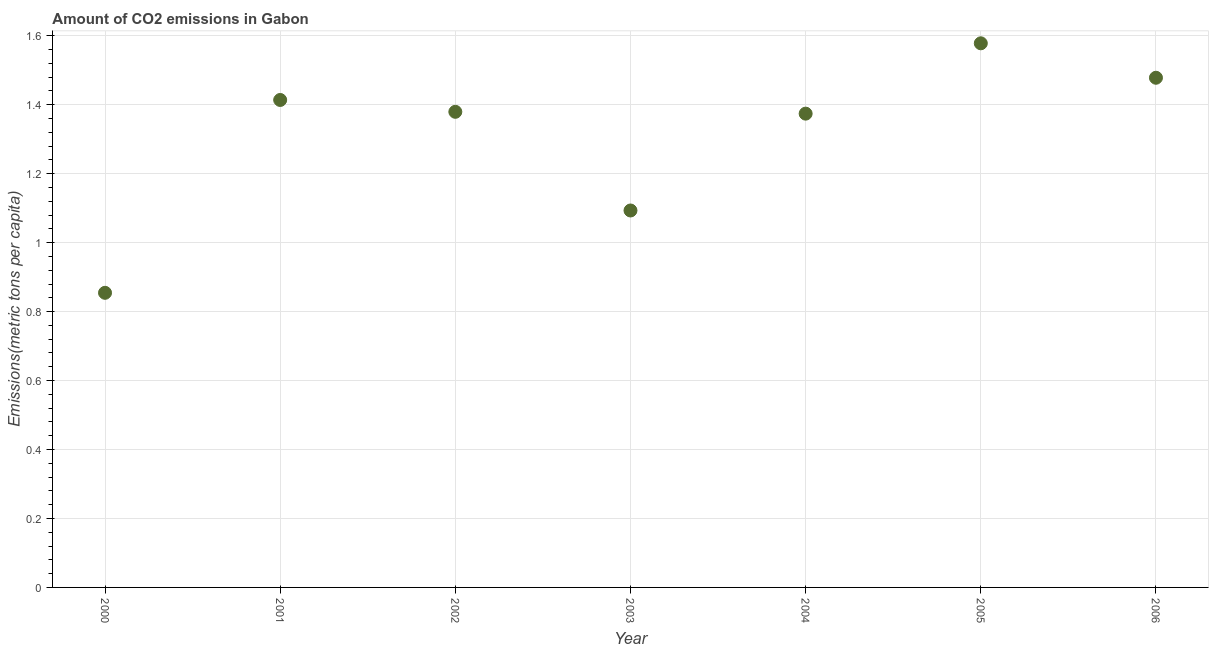What is the amount of co2 emissions in 2006?
Keep it short and to the point. 1.48. Across all years, what is the maximum amount of co2 emissions?
Provide a short and direct response. 1.58. Across all years, what is the minimum amount of co2 emissions?
Ensure brevity in your answer.  0.85. In which year was the amount of co2 emissions maximum?
Provide a short and direct response. 2005. What is the sum of the amount of co2 emissions?
Ensure brevity in your answer.  9.17. What is the difference between the amount of co2 emissions in 2004 and 2005?
Your answer should be very brief. -0.2. What is the average amount of co2 emissions per year?
Keep it short and to the point. 1.31. What is the median amount of co2 emissions?
Your answer should be compact. 1.38. In how many years, is the amount of co2 emissions greater than 0.68 metric tons per capita?
Offer a very short reply. 7. What is the ratio of the amount of co2 emissions in 2003 to that in 2006?
Your answer should be very brief. 0.74. Is the amount of co2 emissions in 2002 less than that in 2005?
Provide a short and direct response. Yes. What is the difference between the highest and the second highest amount of co2 emissions?
Your answer should be very brief. 0.1. What is the difference between the highest and the lowest amount of co2 emissions?
Your answer should be compact. 0.72. In how many years, is the amount of co2 emissions greater than the average amount of co2 emissions taken over all years?
Provide a short and direct response. 5. How many dotlines are there?
Ensure brevity in your answer.  1. Does the graph contain any zero values?
Keep it short and to the point. No. Does the graph contain grids?
Your answer should be very brief. Yes. What is the title of the graph?
Give a very brief answer. Amount of CO2 emissions in Gabon. What is the label or title of the Y-axis?
Make the answer very short. Emissions(metric tons per capita). What is the Emissions(metric tons per capita) in 2000?
Provide a short and direct response. 0.85. What is the Emissions(metric tons per capita) in 2001?
Provide a succinct answer. 1.41. What is the Emissions(metric tons per capita) in 2002?
Your answer should be very brief. 1.38. What is the Emissions(metric tons per capita) in 2003?
Your answer should be very brief. 1.09. What is the Emissions(metric tons per capita) in 2004?
Give a very brief answer. 1.37. What is the Emissions(metric tons per capita) in 2005?
Ensure brevity in your answer.  1.58. What is the Emissions(metric tons per capita) in 2006?
Ensure brevity in your answer.  1.48. What is the difference between the Emissions(metric tons per capita) in 2000 and 2001?
Keep it short and to the point. -0.56. What is the difference between the Emissions(metric tons per capita) in 2000 and 2002?
Your response must be concise. -0.52. What is the difference between the Emissions(metric tons per capita) in 2000 and 2003?
Ensure brevity in your answer.  -0.24. What is the difference between the Emissions(metric tons per capita) in 2000 and 2004?
Your answer should be very brief. -0.52. What is the difference between the Emissions(metric tons per capita) in 2000 and 2005?
Make the answer very short. -0.72. What is the difference between the Emissions(metric tons per capita) in 2000 and 2006?
Keep it short and to the point. -0.62. What is the difference between the Emissions(metric tons per capita) in 2001 and 2002?
Your answer should be very brief. 0.03. What is the difference between the Emissions(metric tons per capita) in 2001 and 2003?
Offer a terse response. 0.32. What is the difference between the Emissions(metric tons per capita) in 2001 and 2004?
Offer a very short reply. 0.04. What is the difference between the Emissions(metric tons per capita) in 2001 and 2005?
Keep it short and to the point. -0.16. What is the difference between the Emissions(metric tons per capita) in 2001 and 2006?
Your response must be concise. -0.06. What is the difference between the Emissions(metric tons per capita) in 2002 and 2003?
Your answer should be very brief. 0.29. What is the difference between the Emissions(metric tons per capita) in 2002 and 2004?
Your answer should be compact. 0.01. What is the difference between the Emissions(metric tons per capita) in 2002 and 2005?
Make the answer very short. -0.2. What is the difference between the Emissions(metric tons per capita) in 2002 and 2006?
Give a very brief answer. -0.1. What is the difference between the Emissions(metric tons per capita) in 2003 and 2004?
Ensure brevity in your answer.  -0.28. What is the difference between the Emissions(metric tons per capita) in 2003 and 2005?
Your response must be concise. -0.48. What is the difference between the Emissions(metric tons per capita) in 2003 and 2006?
Provide a short and direct response. -0.38. What is the difference between the Emissions(metric tons per capita) in 2004 and 2005?
Give a very brief answer. -0.2. What is the difference between the Emissions(metric tons per capita) in 2004 and 2006?
Offer a terse response. -0.1. What is the difference between the Emissions(metric tons per capita) in 2005 and 2006?
Offer a very short reply. 0.1. What is the ratio of the Emissions(metric tons per capita) in 2000 to that in 2001?
Make the answer very short. 0.6. What is the ratio of the Emissions(metric tons per capita) in 2000 to that in 2002?
Provide a succinct answer. 0.62. What is the ratio of the Emissions(metric tons per capita) in 2000 to that in 2003?
Make the answer very short. 0.78. What is the ratio of the Emissions(metric tons per capita) in 2000 to that in 2004?
Give a very brief answer. 0.62. What is the ratio of the Emissions(metric tons per capita) in 2000 to that in 2005?
Provide a short and direct response. 0.54. What is the ratio of the Emissions(metric tons per capita) in 2000 to that in 2006?
Your answer should be very brief. 0.58. What is the ratio of the Emissions(metric tons per capita) in 2001 to that in 2003?
Make the answer very short. 1.29. What is the ratio of the Emissions(metric tons per capita) in 2001 to that in 2004?
Offer a terse response. 1.03. What is the ratio of the Emissions(metric tons per capita) in 2001 to that in 2005?
Your response must be concise. 0.9. What is the ratio of the Emissions(metric tons per capita) in 2001 to that in 2006?
Give a very brief answer. 0.96. What is the ratio of the Emissions(metric tons per capita) in 2002 to that in 2003?
Ensure brevity in your answer.  1.26. What is the ratio of the Emissions(metric tons per capita) in 2002 to that in 2004?
Give a very brief answer. 1. What is the ratio of the Emissions(metric tons per capita) in 2002 to that in 2005?
Make the answer very short. 0.87. What is the ratio of the Emissions(metric tons per capita) in 2002 to that in 2006?
Offer a very short reply. 0.93. What is the ratio of the Emissions(metric tons per capita) in 2003 to that in 2004?
Make the answer very short. 0.8. What is the ratio of the Emissions(metric tons per capita) in 2003 to that in 2005?
Your response must be concise. 0.69. What is the ratio of the Emissions(metric tons per capita) in 2003 to that in 2006?
Your response must be concise. 0.74. What is the ratio of the Emissions(metric tons per capita) in 2004 to that in 2005?
Your response must be concise. 0.87. What is the ratio of the Emissions(metric tons per capita) in 2005 to that in 2006?
Offer a terse response. 1.07. 